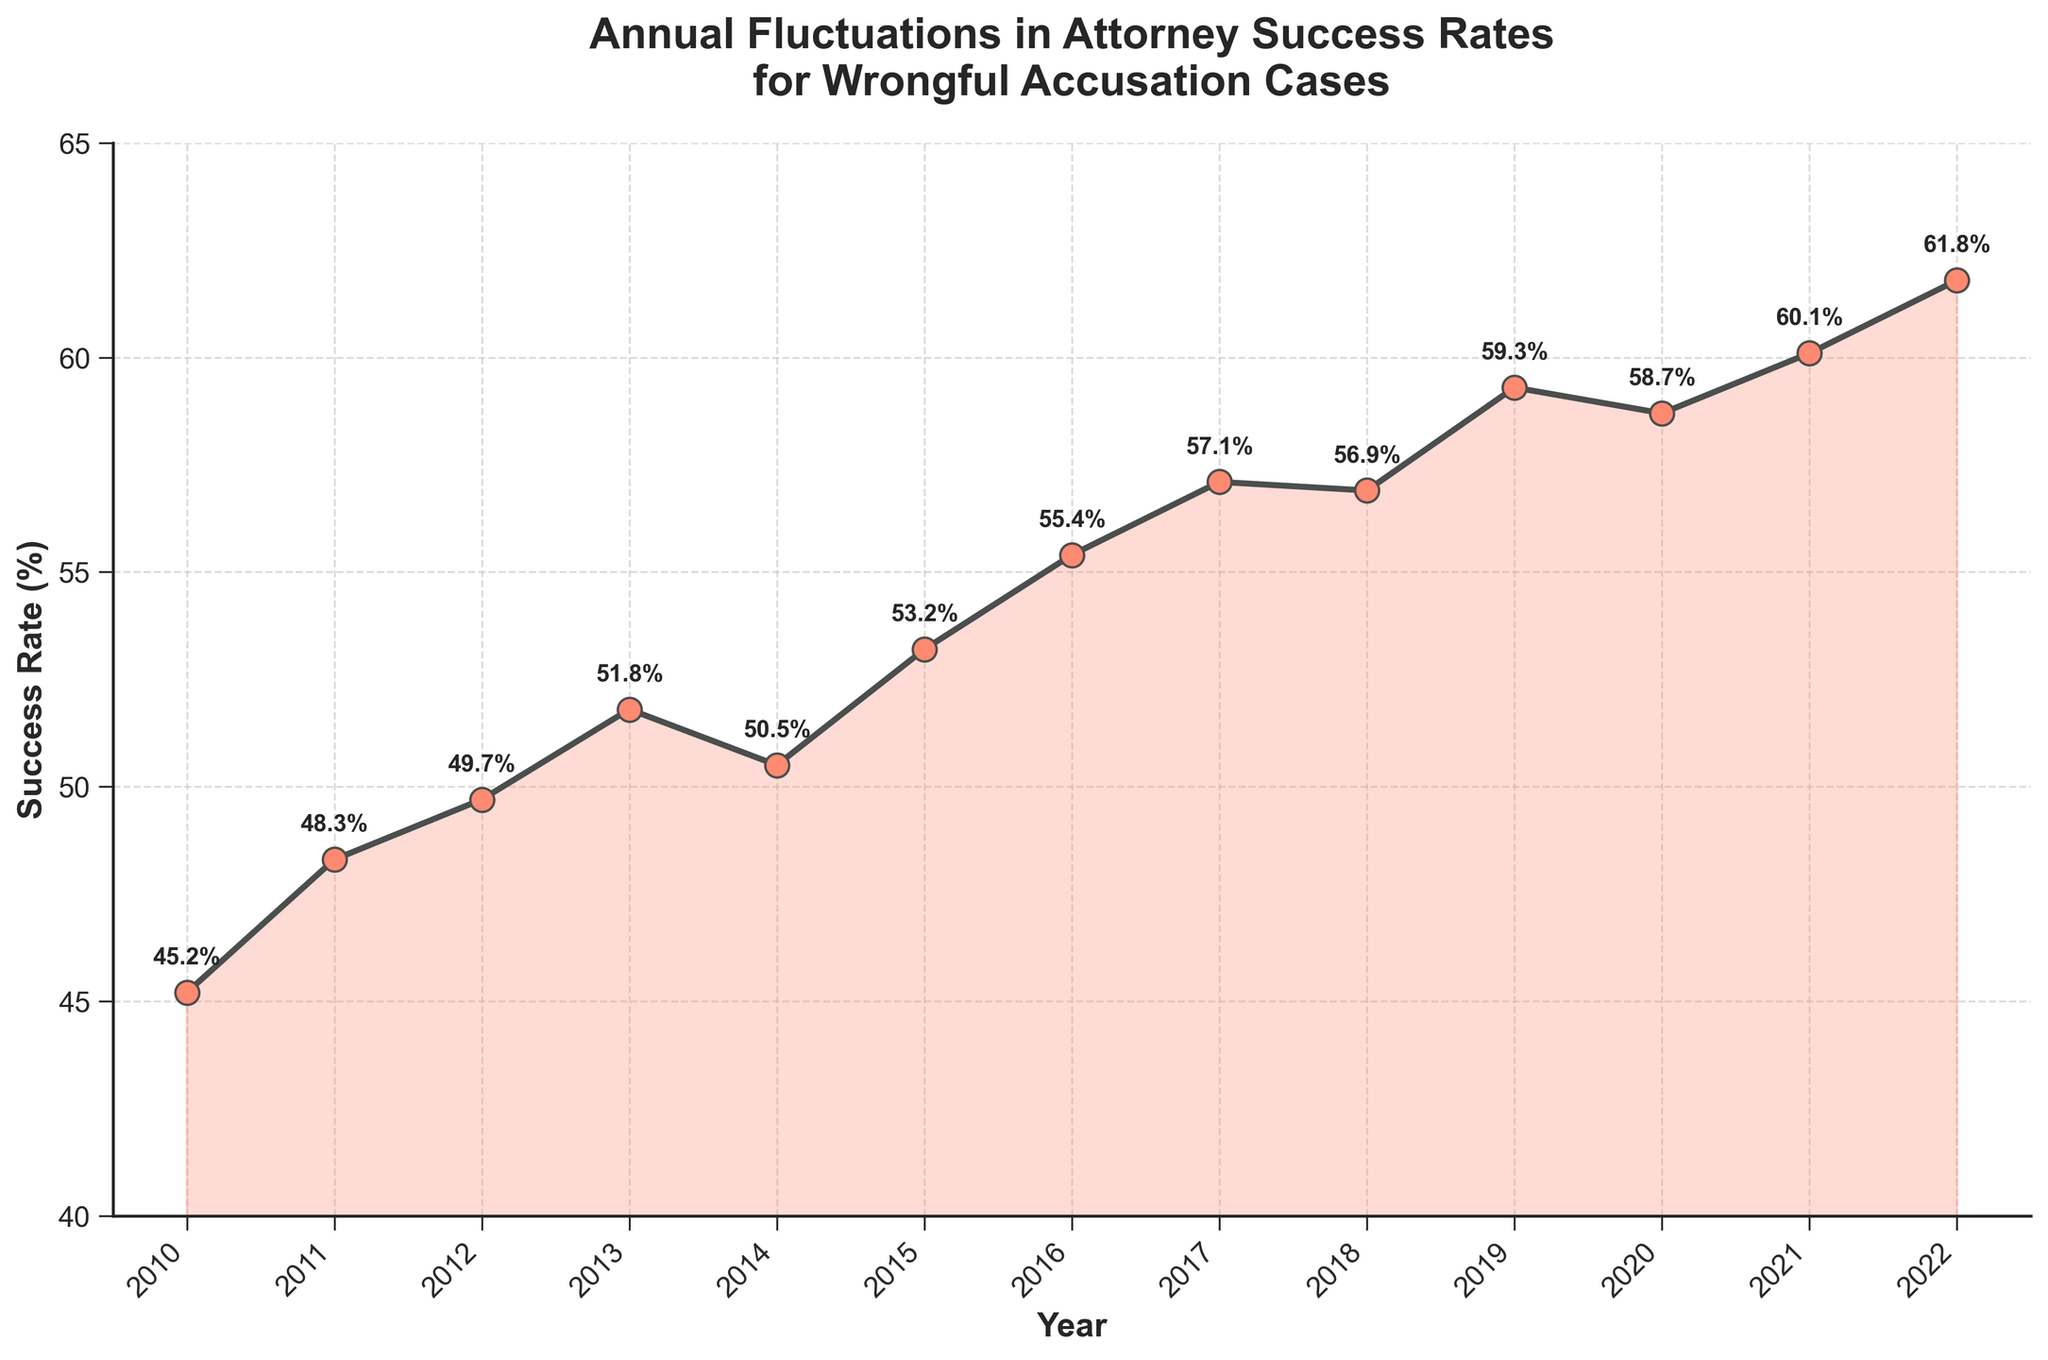What is the title of the plot? The title is located at the top of the figure. It reads "Annual Fluctuations in Attorney Success Rates for Wrongful Accusation Cases".
Answer: Annual Fluctuations in Attorney Success Rates for Wrongful Accusation Cases What is the success rate in 2010? The success rate for each year is plotted as a data point with a labeled percentage. For 2010, the label shows 45.2%.
Answer: 45.2% How many years does the plot cover? To find the range, subtract the initial year (2010) from the final year (2022) and add one (2010 to 2022 inclusive). This provides a span of 13 years.
Answer: 13 years Which year had the highest success rate? By identifying the peak point on the plot, the highest success rate occurs in the year 2022, showing a rate of 61.8%.
Answer: 2022 What was the success rate change from 2013 to 2014? The success rate in 2013 was 51.8%, and in 2014 it was 50.5%. The change is the difference between these two values: 51.8% - 50.5% = 1.3% drop.
Answer: -1.3% Which year saw the largest increase in success rate compared to the previous year? By analyzing year-over-year differences, the largest increase is from 2011 to 2012, where the success rate rose from 48.3% to 49.7%, an increase of 1.4%.
Answer: 2011 to 2012 What is the average success rate over the entire period? Sum all the success rates and divide by the number of years: (45.2 + 48.3 + 49.7 + 51.8 + 50.5 + 53.2 + 55.4 + 57.1 + 56.9 + 59.3 + 58.7 + 60.1 + 61.8)/13 ≈ 53.9%.
Answer: 53.9% How does the success rate in 2020 compare to 2022? The success rate in 2020 was 58.7% and in 2022 was 61.8%. The increase is 61.8% - 58.7% = 3.1%.
Answer: 3.1% higher Which years have a success rate above 55%? Observing the plot, the years with a success rate above 55% are 2016, 2017, 2018, 2019, 2020, 2021, and 2022.
Answer: 2016, 2017, 2018, 2019, 2020, 2021, 2022 